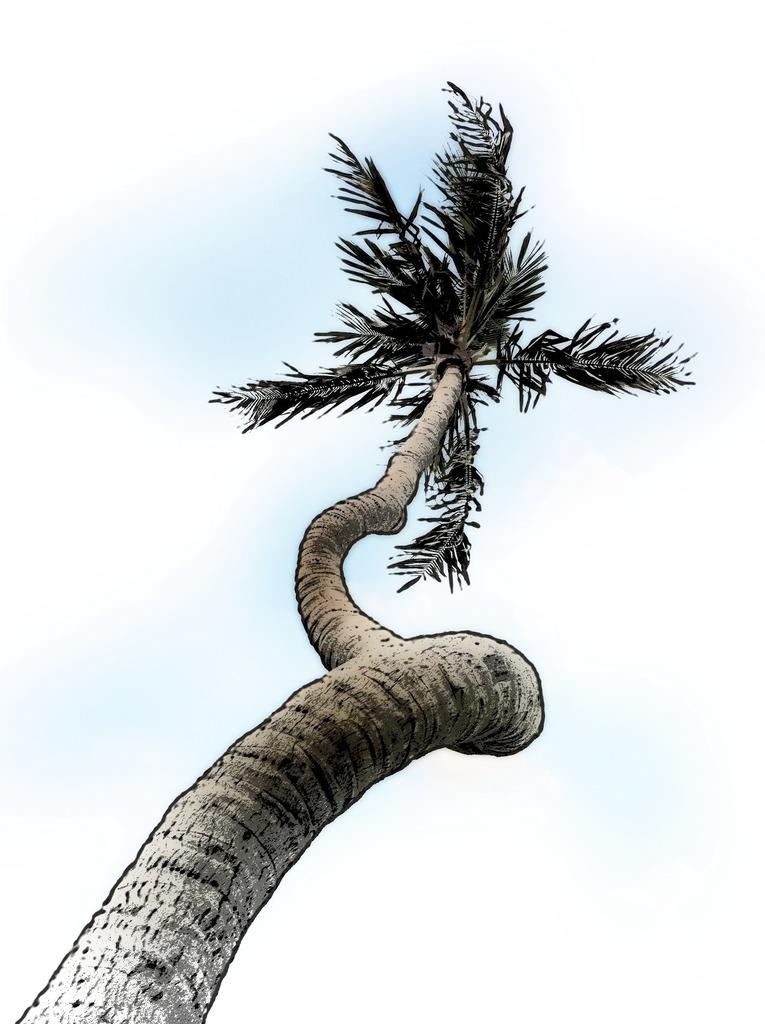What is depicted in the drawing in the image? There is a drawing of a tree in the image. What can be seen in the background of the drawing? There is a sky visible in the image. How many tigers are participating in the competition in the image? There are no tigers or competition present in the image; it features a drawing of a tree and a visible sky. 